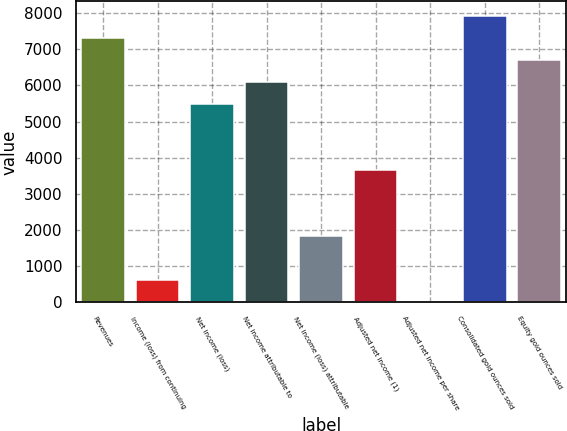Convert chart. <chart><loc_0><loc_0><loc_500><loc_500><bar_chart><fcel>Revenues<fcel>Income (loss) from continuing<fcel>Net income (loss)<fcel>Net income attributable to<fcel>Net income (loss) attributable<fcel>Adjusted net income (1)<fcel>Adjusted net income per share<fcel>Consolidated gold ounces sold<fcel>Equity gold ounces sold<nl><fcel>7316.12<fcel>610.74<fcel>5487.38<fcel>6096.96<fcel>1829.9<fcel>3658.64<fcel>1.16<fcel>7925.7<fcel>6706.54<nl></chart> 